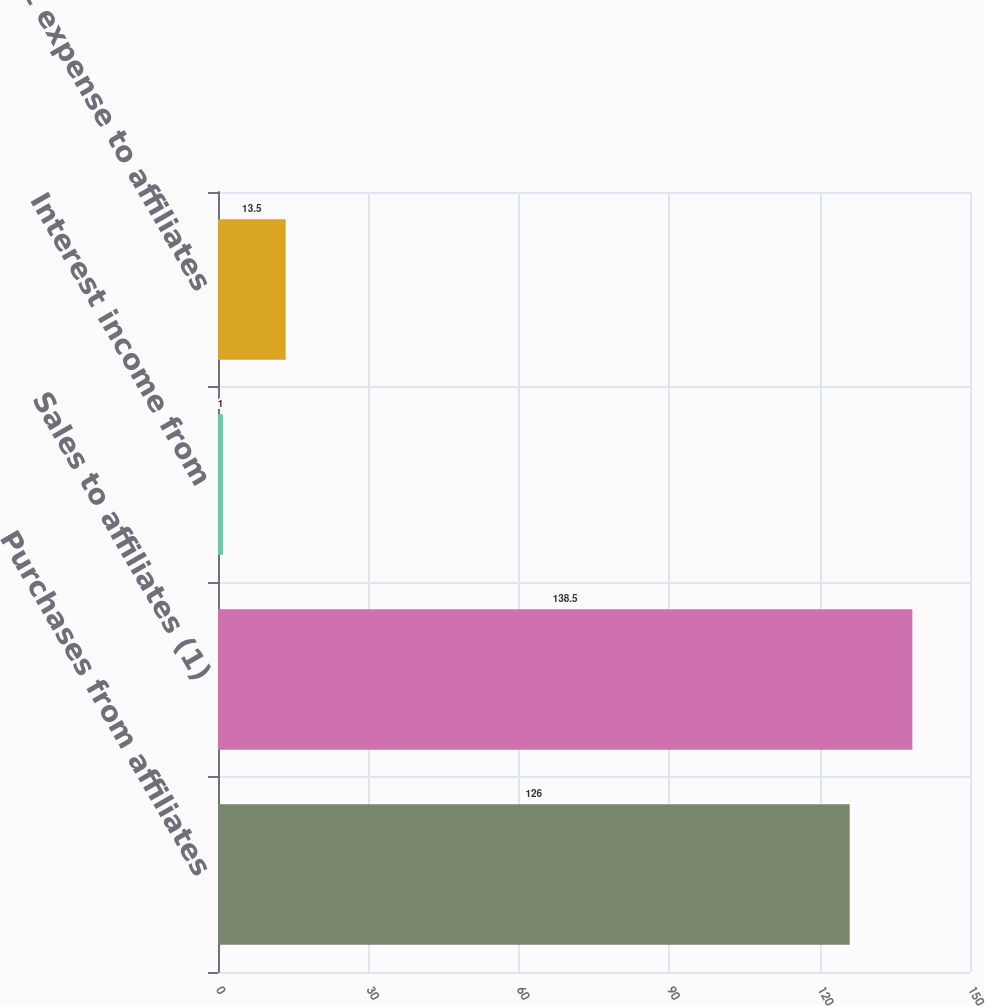Convert chart. <chart><loc_0><loc_0><loc_500><loc_500><bar_chart><fcel>Purchases from affiliates<fcel>Sales to affiliates (1)<fcel>Interest income from<fcel>Interest expense to affiliates<nl><fcel>126<fcel>138.5<fcel>1<fcel>13.5<nl></chart> 